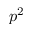<formula> <loc_0><loc_0><loc_500><loc_500>p ^ { 2 }</formula> 